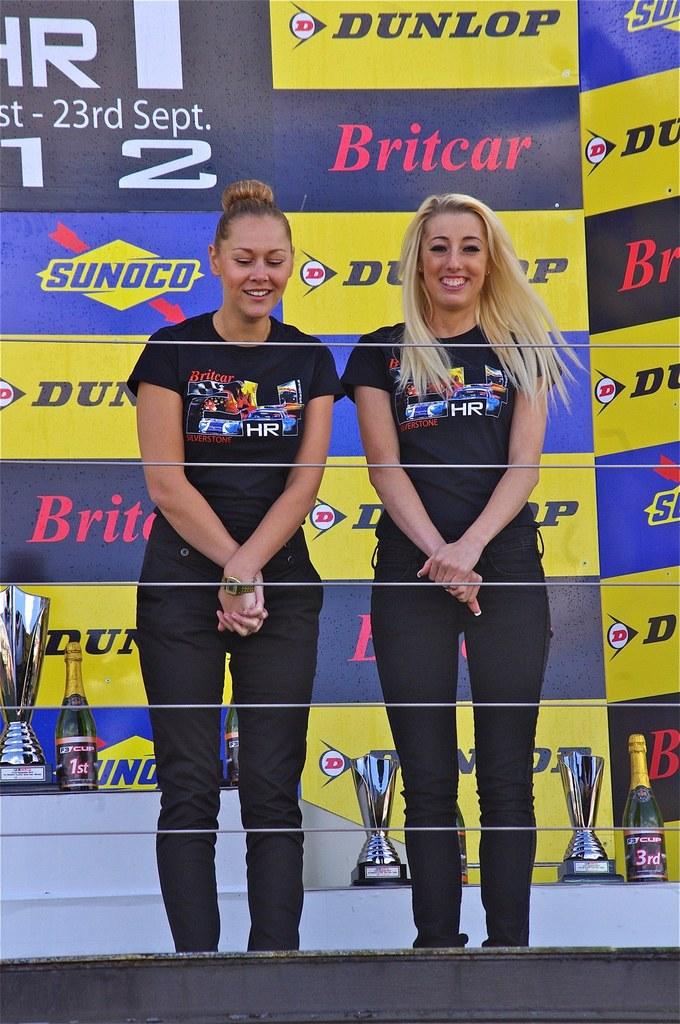What date can we see in the top left?
Provide a succinct answer. 23rd sept. 